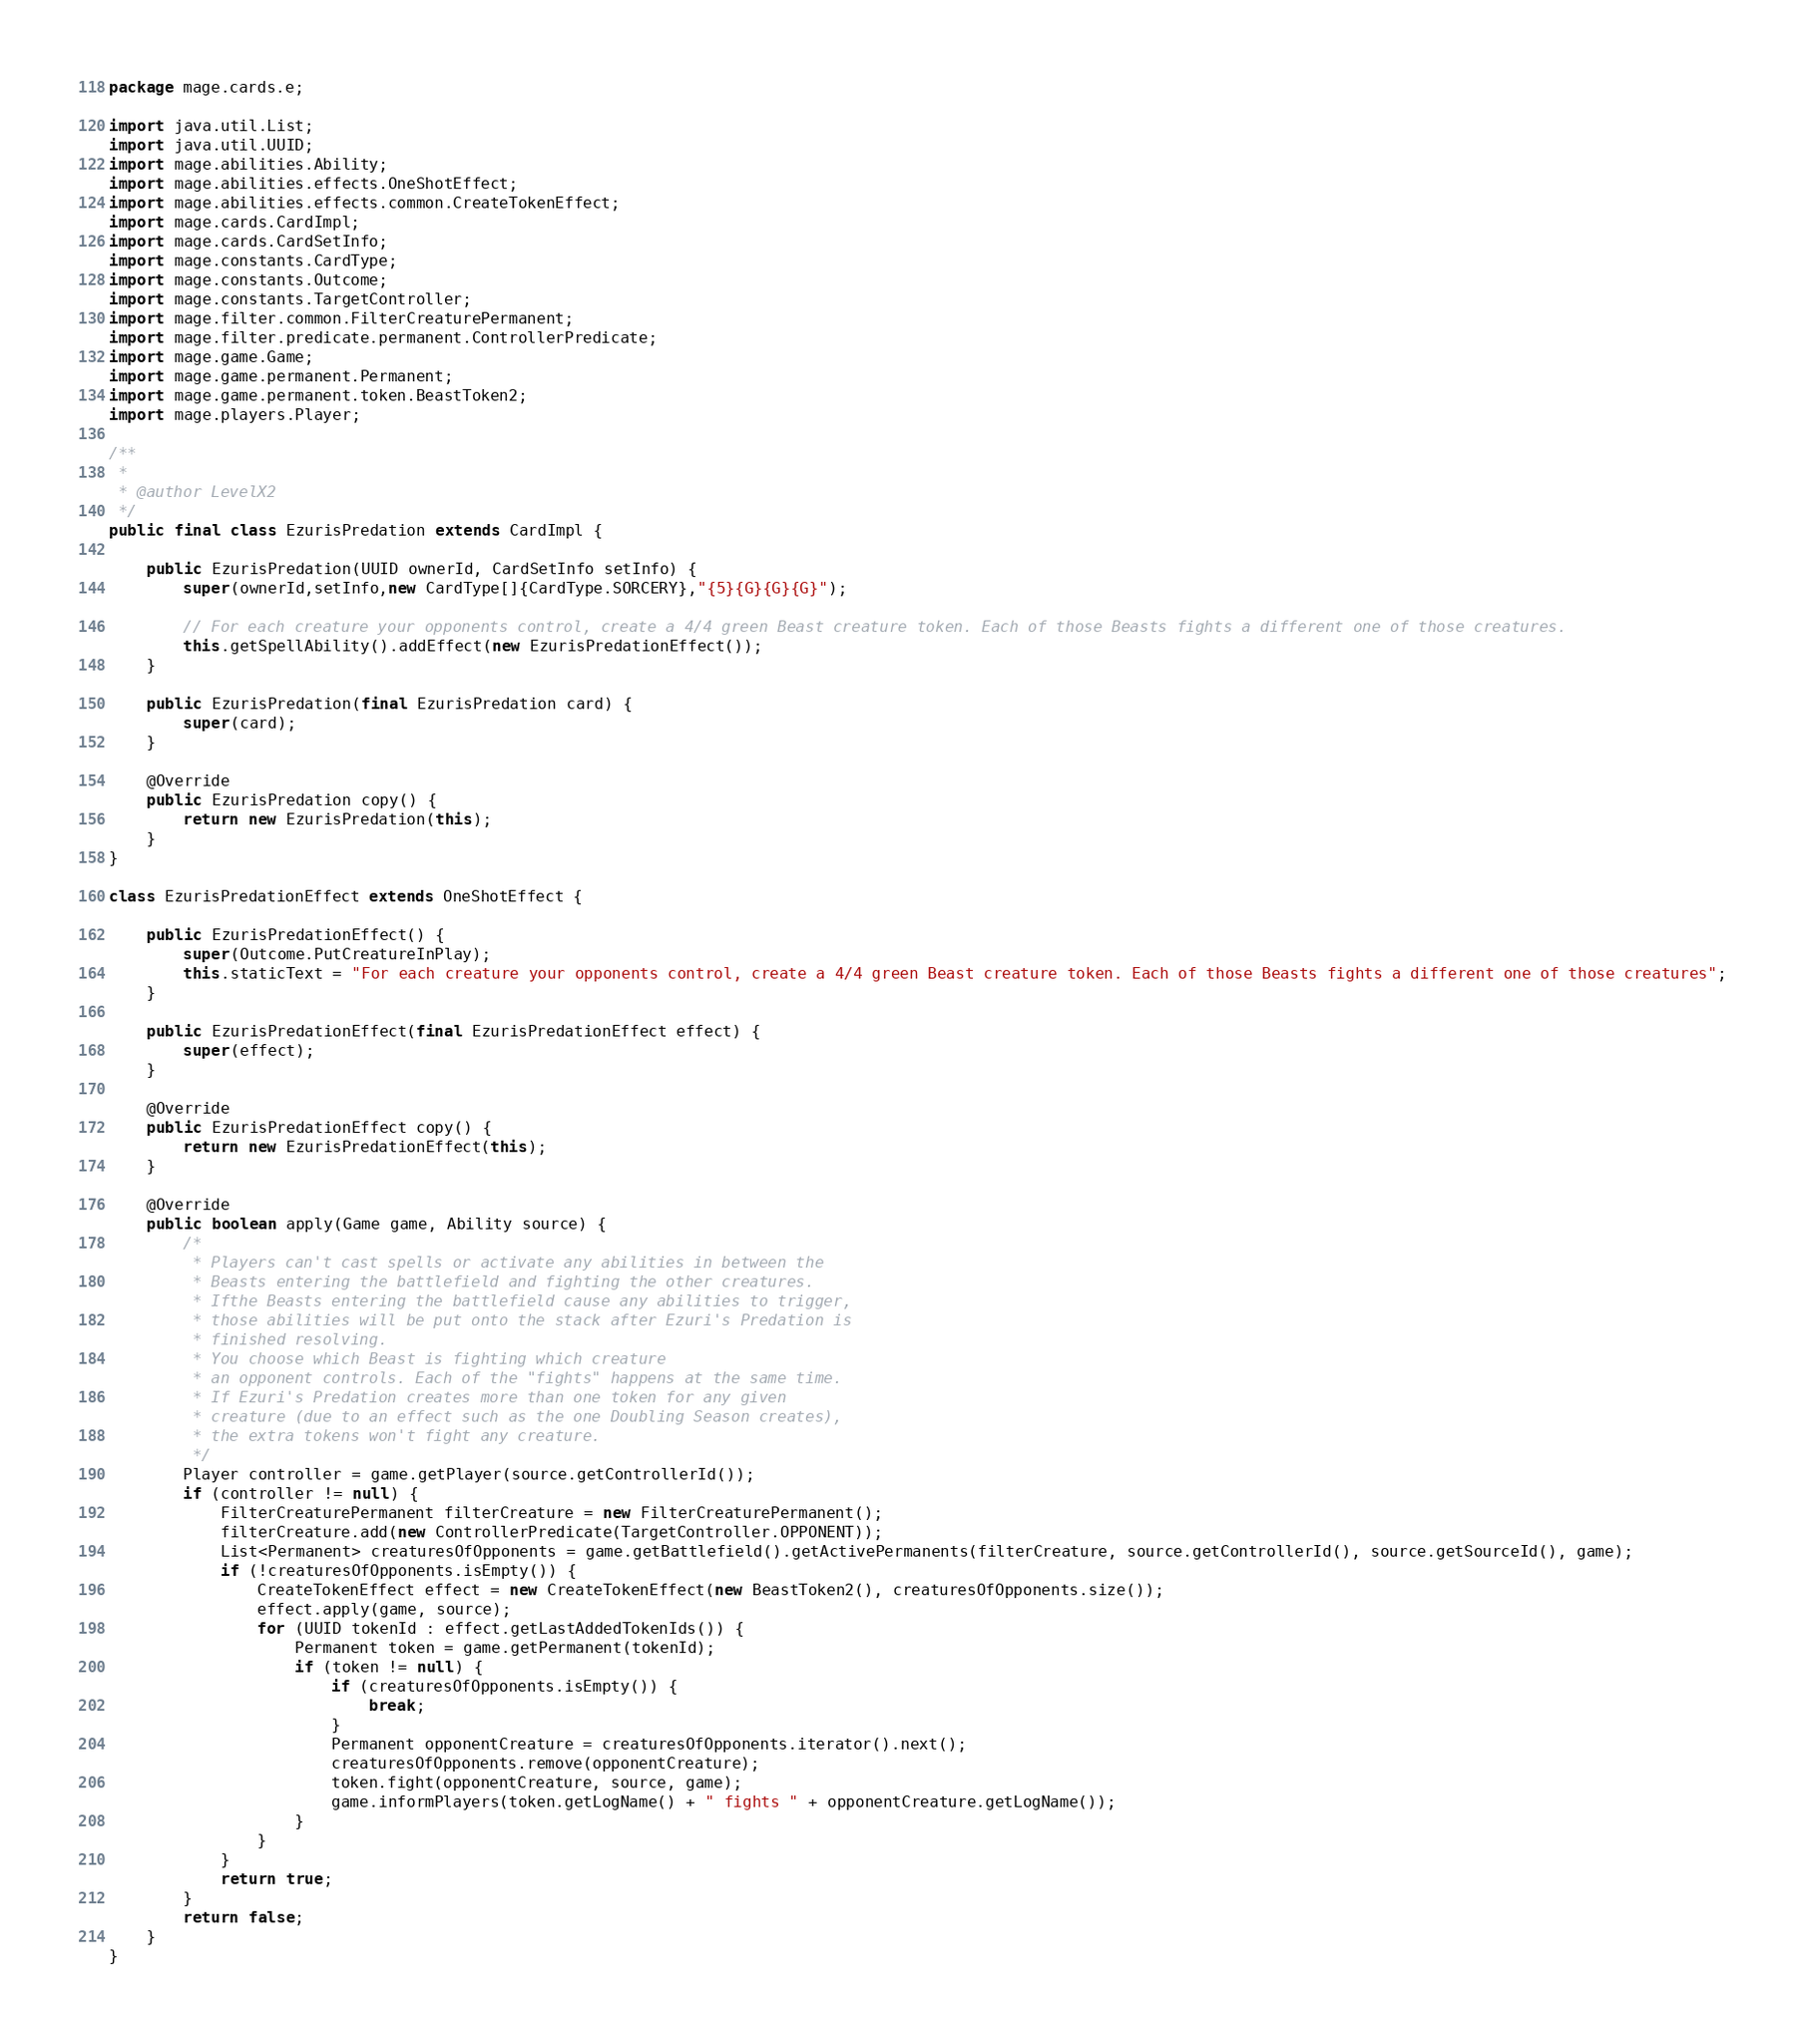<code> <loc_0><loc_0><loc_500><loc_500><_Java_>
package mage.cards.e;

import java.util.List;
import java.util.UUID;
import mage.abilities.Ability;
import mage.abilities.effects.OneShotEffect;
import mage.abilities.effects.common.CreateTokenEffect;
import mage.cards.CardImpl;
import mage.cards.CardSetInfo;
import mage.constants.CardType;
import mage.constants.Outcome;
import mage.constants.TargetController;
import mage.filter.common.FilterCreaturePermanent;
import mage.filter.predicate.permanent.ControllerPredicate;
import mage.game.Game;
import mage.game.permanent.Permanent;
import mage.game.permanent.token.BeastToken2;
import mage.players.Player;

/**
 *
 * @author LevelX2
 */
public final class EzurisPredation extends CardImpl {

    public EzurisPredation(UUID ownerId, CardSetInfo setInfo) {
        super(ownerId,setInfo,new CardType[]{CardType.SORCERY},"{5}{G}{G}{G}");

        // For each creature your opponents control, create a 4/4 green Beast creature token. Each of those Beasts fights a different one of those creatures.
        this.getSpellAbility().addEffect(new EzurisPredationEffect());
    }

    public EzurisPredation(final EzurisPredation card) {
        super(card);
    }

    @Override
    public EzurisPredation copy() {
        return new EzurisPredation(this);
    }
}

class EzurisPredationEffect extends OneShotEffect {

    public EzurisPredationEffect() {
        super(Outcome.PutCreatureInPlay);
        this.staticText = "For each creature your opponents control, create a 4/4 green Beast creature token. Each of those Beasts fights a different one of those creatures";
    }

    public EzurisPredationEffect(final EzurisPredationEffect effect) {
        super(effect);
    }

    @Override
    public EzurisPredationEffect copy() {
        return new EzurisPredationEffect(this);
    }

    @Override
    public boolean apply(Game game, Ability source) {
        /*
         * Players can't cast spells or activate any abilities in between the
         * Beasts entering the battlefield and fighting the other creatures.
         * Ifthe Beasts entering the battlefield cause any abilities to trigger,
         * those abilities will be put onto the stack after Ezuri's Predation is
         * finished resolving.
         * You choose which Beast is fighting which creature
         * an opponent controls. Each of the "fights" happens at the same time.
         * If Ezuri's Predation creates more than one token for any given
         * creature (due to an effect such as the one Doubling Season creates),
         * the extra tokens won't fight any creature.
         */
        Player controller = game.getPlayer(source.getControllerId());
        if (controller != null) {
            FilterCreaturePermanent filterCreature = new FilterCreaturePermanent();
            filterCreature.add(new ControllerPredicate(TargetController.OPPONENT));
            List<Permanent> creaturesOfOpponents = game.getBattlefield().getActivePermanents(filterCreature, source.getControllerId(), source.getSourceId(), game);
            if (!creaturesOfOpponents.isEmpty()) {
                CreateTokenEffect effect = new CreateTokenEffect(new BeastToken2(), creaturesOfOpponents.size());
                effect.apply(game, source);
                for (UUID tokenId : effect.getLastAddedTokenIds()) {
                    Permanent token = game.getPermanent(tokenId);
                    if (token != null) {
                        if (creaturesOfOpponents.isEmpty()) {
                            break;
                        }
                        Permanent opponentCreature = creaturesOfOpponents.iterator().next();
                        creaturesOfOpponents.remove(opponentCreature);
                        token.fight(opponentCreature, source, game);
                        game.informPlayers(token.getLogName() + " fights " + opponentCreature.getLogName());
                    }
                }
            }
            return true;
        }
        return false;
    }
}
</code> 